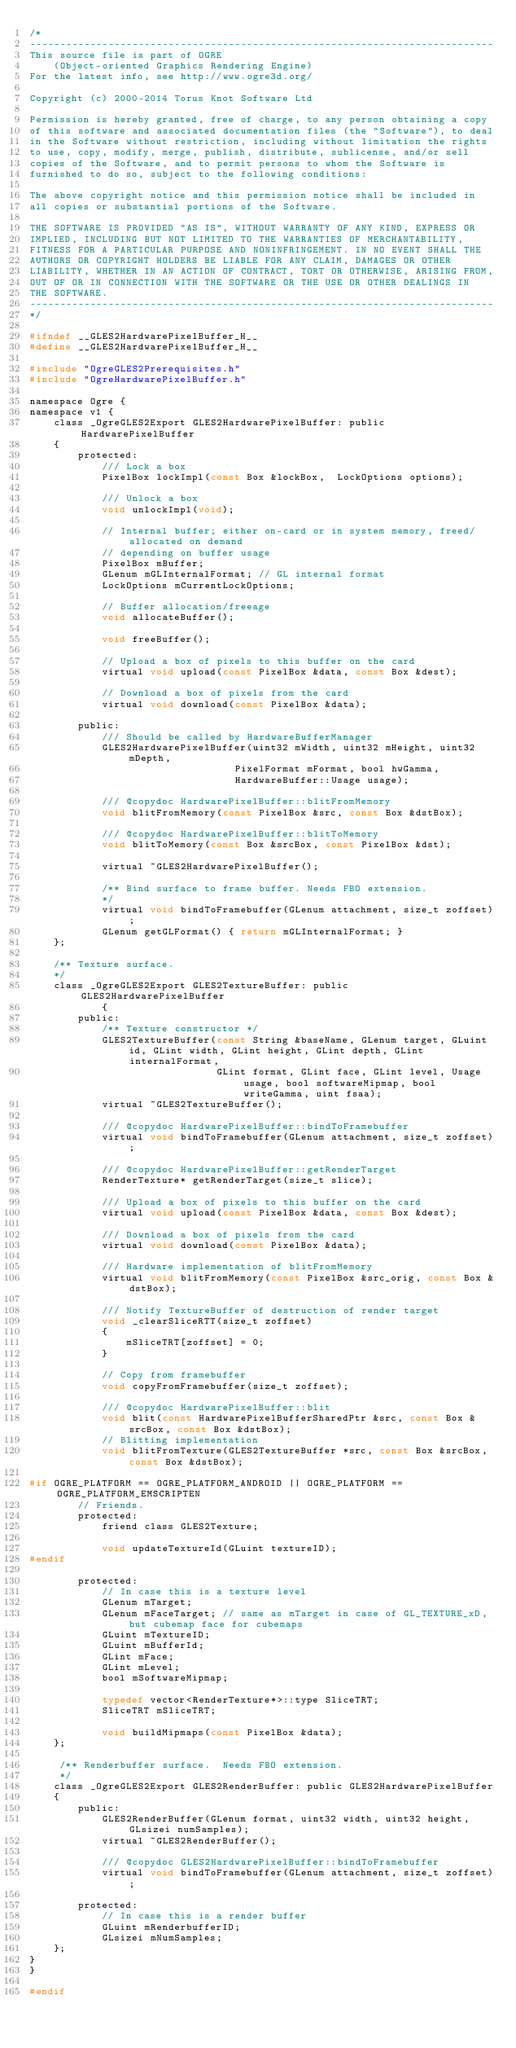Convert code to text. <code><loc_0><loc_0><loc_500><loc_500><_C_>/*
-----------------------------------------------------------------------------
This source file is part of OGRE
    (Object-oriented Graphics Rendering Engine)
For the latest info, see http://www.ogre3d.org/

Copyright (c) 2000-2014 Torus Knot Software Ltd

Permission is hereby granted, free of charge, to any person obtaining a copy
of this software and associated documentation files (the "Software"), to deal
in the Software without restriction, including without limitation the rights
to use, copy, modify, merge, publish, distribute, sublicense, and/or sell
copies of the Software, and to permit persons to whom the Software is
furnished to do so, subject to the following conditions:

The above copyright notice and this permission notice shall be included in
all copies or substantial portions of the Software.

THE SOFTWARE IS PROVIDED "AS IS", WITHOUT WARRANTY OF ANY KIND, EXPRESS OR
IMPLIED, INCLUDING BUT NOT LIMITED TO THE WARRANTIES OF MERCHANTABILITY,
FITNESS FOR A PARTICULAR PURPOSE AND NONINFRINGEMENT. IN NO EVENT SHALL THE
AUTHORS OR COPYRIGHT HOLDERS BE LIABLE FOR ANY CLAIM, DAMAGES OR OTHER
LIABILITY, WHETHER IN AN ACTION OF CONTRACT, TORT OR OTHERWISE, ARISING FROM,
OUT OF OR IN CONNECTION WITH THE SOFTWARE OR THE USE OR OTHER DEALINGS IN
THE SOFTWARE.
-----------------------------------------------------------------------------
*/

#ifndef __GLES2HardwarePixelBuffer_H__
#define __GLES2HardwarePixelBuffer_H__

#include "OgreGLES2Prerequisites.h"
#include "OgreHardwarePixelBuffer.h"

namespace Ogre {
namespace v1 {
    class _OgreGLES2Export GLES2HardwarePixelBuffer: public HardwarePixelBuffer
    {
        protected:
            /// Lock a box
            PixelBox lockImpl(const Box &lockBox,  LockOptions options);

            /// Unlock a box
            void unlockImpl(void);

            // Internal buffer; either on-card or in system memory, freed/allocated on demand
            // depending on buffer usage
            PixelBox mBuffer;
            GLenum mGLInternalFormat; // GL internal format
            LockOptions mCurrentLockOptions;

            // Buffer allocation/freeage
            void allocateBuffer();

            void freeBuffer();

            // Upload a box of pixels to this buffer on the card
            virtual void upload(const PixelBox &data, const Box &dest);

            // Download a box of pixels from the card
            virtual void download(const PixelBox &data);
        
        public:
            /// Should be called by HardwareBufferManager
            GLES2HardwarePixelBuffer(uint32 mWidth, uint32 mHeight, uint32 mDepth,
                                  PixelFormat mFormat, bool hwGamma,
                                  HardwareBuffer::Usage usage);

            /// @copydoc HardwarePixelBuffer::blitFromMemory
            void blitFromMemory(const PixelBox &src, const Box &dstBox);

            /// @copydoc HardwarePixelBuffer::blitToMemory
            void blitToMemory(const Box &srcBox, const PixelBox &dst);

            virtual ~GLES2HardwarePixelBuffer();

            /** Bind surface to frame buffer. Needs FBO extension.
            */
            virtual void bindToFramebuffer(GLenum attachment, size_t zoffset);
            GLenum getGLFormat() { return mGLInternalFormat; }
    };

    /** Texture surface.
    */
    class _OgreGLES2Export GLES2TextureBuffer: public GLES2HardwarePixelBuffer
            {
        public:
            /** Texture constructor */
            GLES2TextureBuffer(const String &baseName, GLenum target, GLuint id, GLint width, GLint height, GLint depth, GLint internalFormat,
                               GLint format, GLint face, GLint level, Usage usage, bool softwareMipmap, bool writeGamma, uint fsaa);
            virtual ~GLES2TextureBuffer();

            /// @copydoc HardwarePixelBuffer::bindToFramebuffer
            virtual void bindToFramebuffer(GLenum attachment, size_t zoffset);

            /// @copydoc HardwarePixelBuffer::getRenderTarget
            RenderTexture* getRenderTarget(size_t slice);

            /// Upload a box of pixels to this buffer on the card
            virtual void upload(const PixelBox &data, const Box &dest);

            /// Download a box of pixels from the card
            virtual void download(const PixelBox &data);

            /// Hardware implementation of blitFromMemory
            virtual void blitFromMemory(const PixelBox &src_orig, const Box &dstBox);

            /// Notify TextureBuffer of destruction of render target
            void _clearSliceRTT(size_t zoffset)
            {
                mSliceTRT[zoffset] = 0;
            }

            // Copy from framebuffer
            void copyFromFramebuffer(size_t zoffset);

            /// @copydoc HardwarePixelBuffer::blit
            void blit(const HardwarePixelBufferSharedPtr &src, const Box &srcBox, const Box &dstBox);
            // Blitting implementation
            void blitFromTexture(GLES2TextureBuffer *src, const Box &srcBox, const Box &dstBox);
            
#if OGRE_PLATFORM == OGRE_PLATFORM_ANDROID || OGRE_PLATFORM == OGRE_PLATFORM_EMSCRIPTEN
        // Friends.
        protected:
            friend class GLES2Texture;
                
            void updateTextureId(GLuint textureID);
#endif
                
        protected:
            // In case this is a texture level
            GLenum mTarget;
            GLenum mFaceTarget; // same as mTarget in case of GL_TEXTURE_xD, but cubemap face for cubemaps
            GLuint mTextureID;
            GLuint mBufferId;
            GLint mFace;
            GLint mLevel;
            bool mSoftwareMipmap;
                
            typedef vector<RenderTexture*>::type SliceTRT;
            SliceTRT mSliceTRT;

            void buildMipmaps(const PixelBox &data);
    };

     /** Renderbuffer surface.  Needs FBO extension.
     */
    class _OgreGLES2Export GLES2RenderBuffer: public GLES2HardwarePixelBuffer
    {
        public:
            GLES2RenderBuffer(GLenum format, uint32 width, uint32 height, GLsizei numSamples);
            virtual ~GLES2RenderBuffer();

            /// @copydoc GLES2HardwarePixelBuffer::bindToFramebuffer
            virtual void bindToFramebuffer(GLenum attachment, size_t zoffset);

        protected:
            // In case this is a render buffer
            GLuint mRenderbufferID;
            GLsizei mNumSamples;
    };
}
}

#endif
</code> 